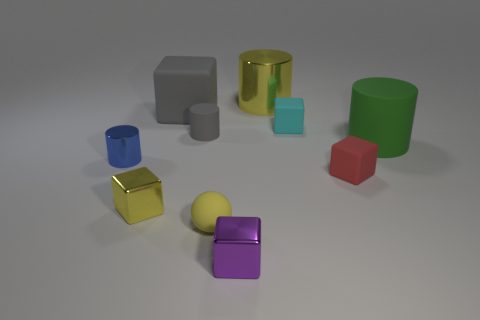What is the overall theme or style of the objects in the image? The objects in the image exhibit a minimalist style with simple geometric shapes and a variety of solid matte and glossy surfaces, suggesting a focus on fundamental forms and materials often seen in educational or design-oriented settings. 